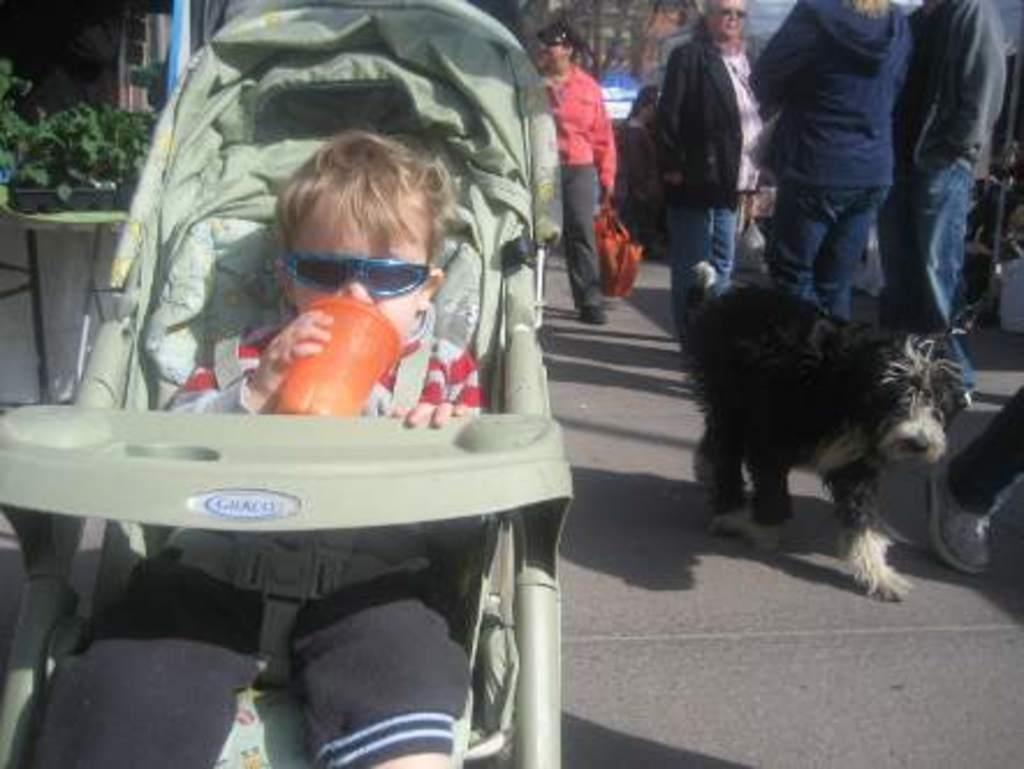What can be seen in the image involving people? There are people standing in the image. What animal is present in the image? There is a dog in the image. What is the child in the image doing? The child is sitting in a trolley and holding a glass. What type of vegetation is visible in the image? There are plants in the image. What type of pest can be seen in the image? There is no pest present in the image. What is the dog using to rake the leaves in the image? The image does not show the dog raking leaves, nor is there a rake present. 